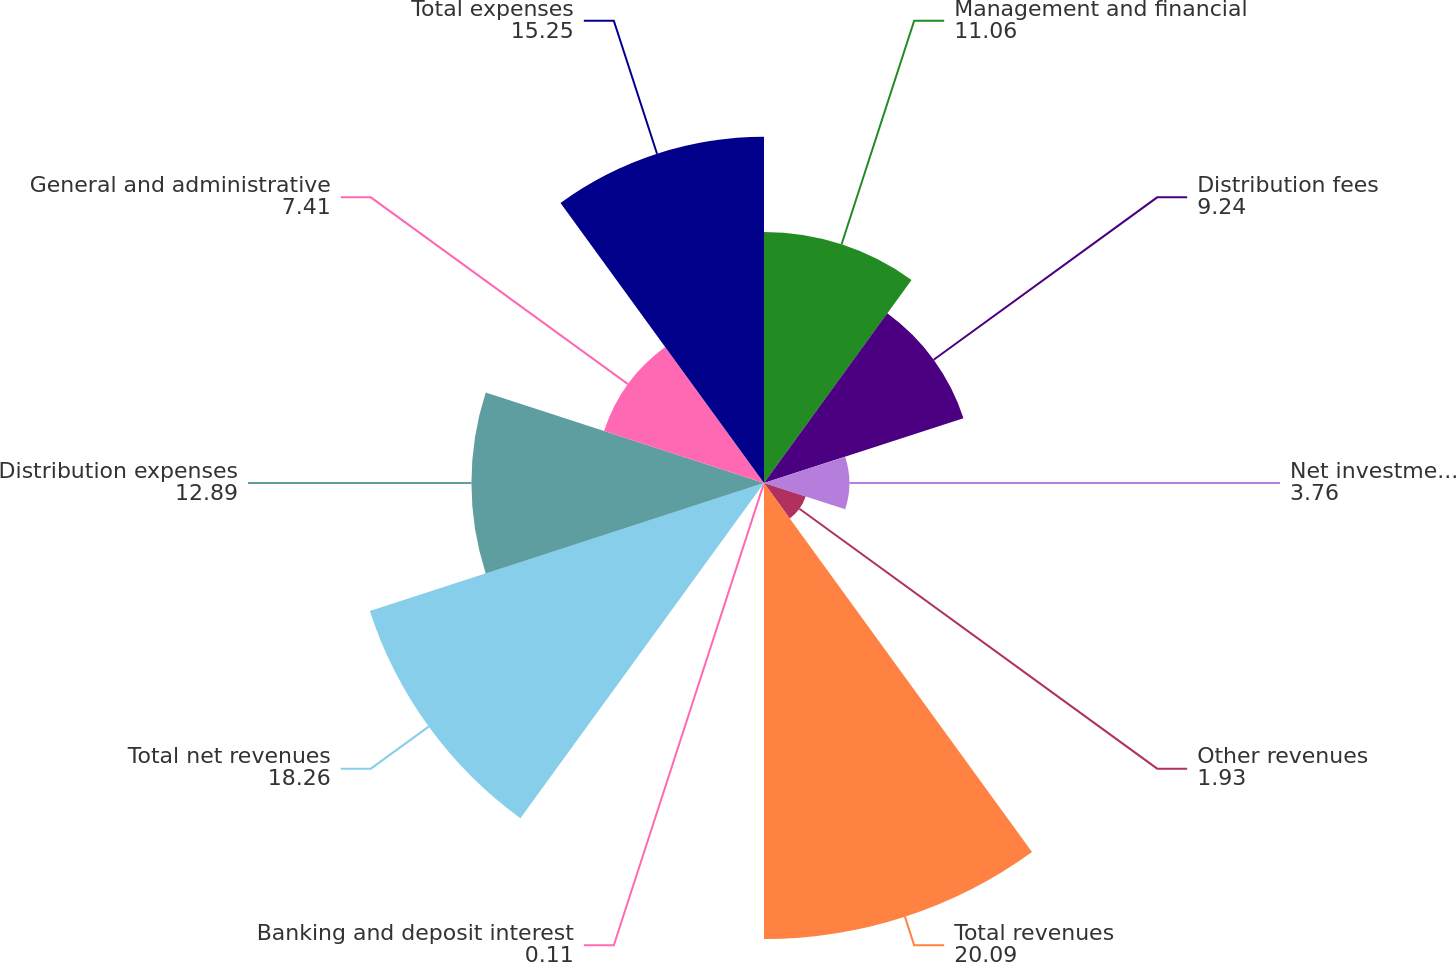Convert chart. <chart><loc_0><loc_0><loc_500><loc_500><pie_chart><fcel>Management and financial<fcel>Distribution fees<fcel>Net investment income<fcel>Other revenues<fcel>Total revenues<fcel>Banking and deposit interest<fcel>Total net revenues<fcel>Distribution expenses<fcel>General and administrative<fcel>Total expenses<nl><fcel>11.06%<fcel>9.24%<fcel>3.76%<fcel>1.93%<fcel>20.09%<fcel>0.11%<fcel>18.26%<fcel>12.89%<fcel>7.41%<fcel>15.25%<nl></chart> 